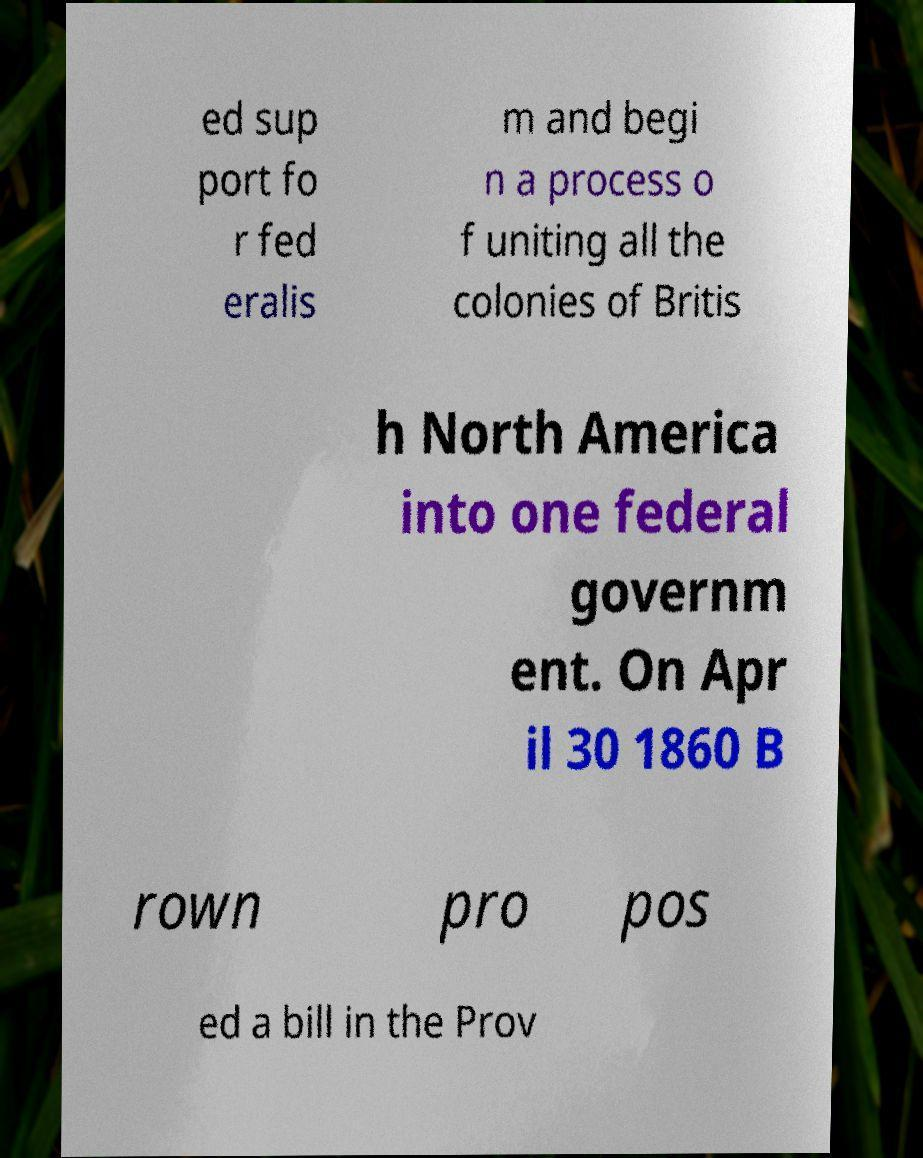Could you assist in decoding the text presented in this image and type it out clearly? ed sup port fo r fed eralis m and begi n a process o f uniting all the colonies of Britis h North America into one federal governm ent. On Apr il 30 1860 B rown pro pos ed a bill in the Prov 